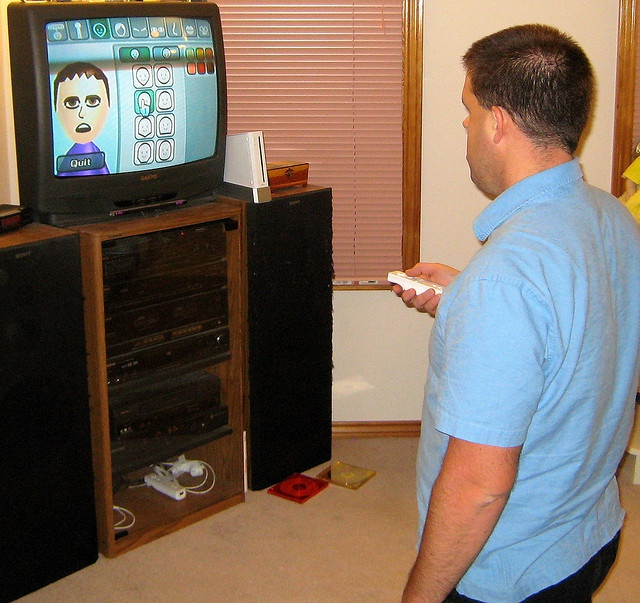Describe the objects in this image and their specific colors. I can see people in khaki, lightblue, and darkgray tones, tv in khaki, black, white, lightblue, and maroon tones, and remote in khaki, ivory, and gray tones in this image. 